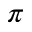<formula> <loc_0><loc_0><loc_500><loc_500>\pi</formula> 